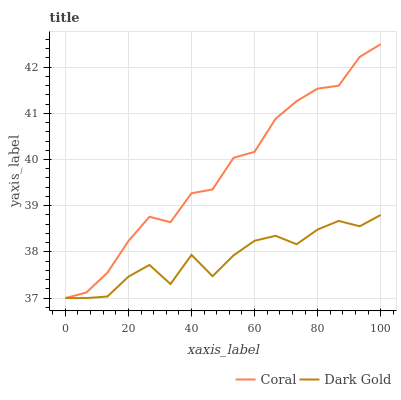Does Dark Gold have the minimum area under the curve?
Answer yes or no. Yes. Does Coral have the maximum area under the curve?
Answer yes or no. Yes. Does Dark Gold have the maximum area under the curve?
Answer yes or no. No. Is Coral the smoothest?
Answer yes or no. Yes. Is Dark Gold the roughest?
Answer yes or no. Yes. Is Dark Gold the smoothest?
Answer yes or no. No. Does Coral have the highest value?
Answer yes or no. Yes. Does Dark Gold have the highest value?
Answer yes or no. No. Does Coral intersect Dark Gold?
Answer yes or no. Yes. Is Coral less than Dark Gold?
Answer yes or no. No. Is Coral greater than Dark Gold?
Answer yes or no. No. 